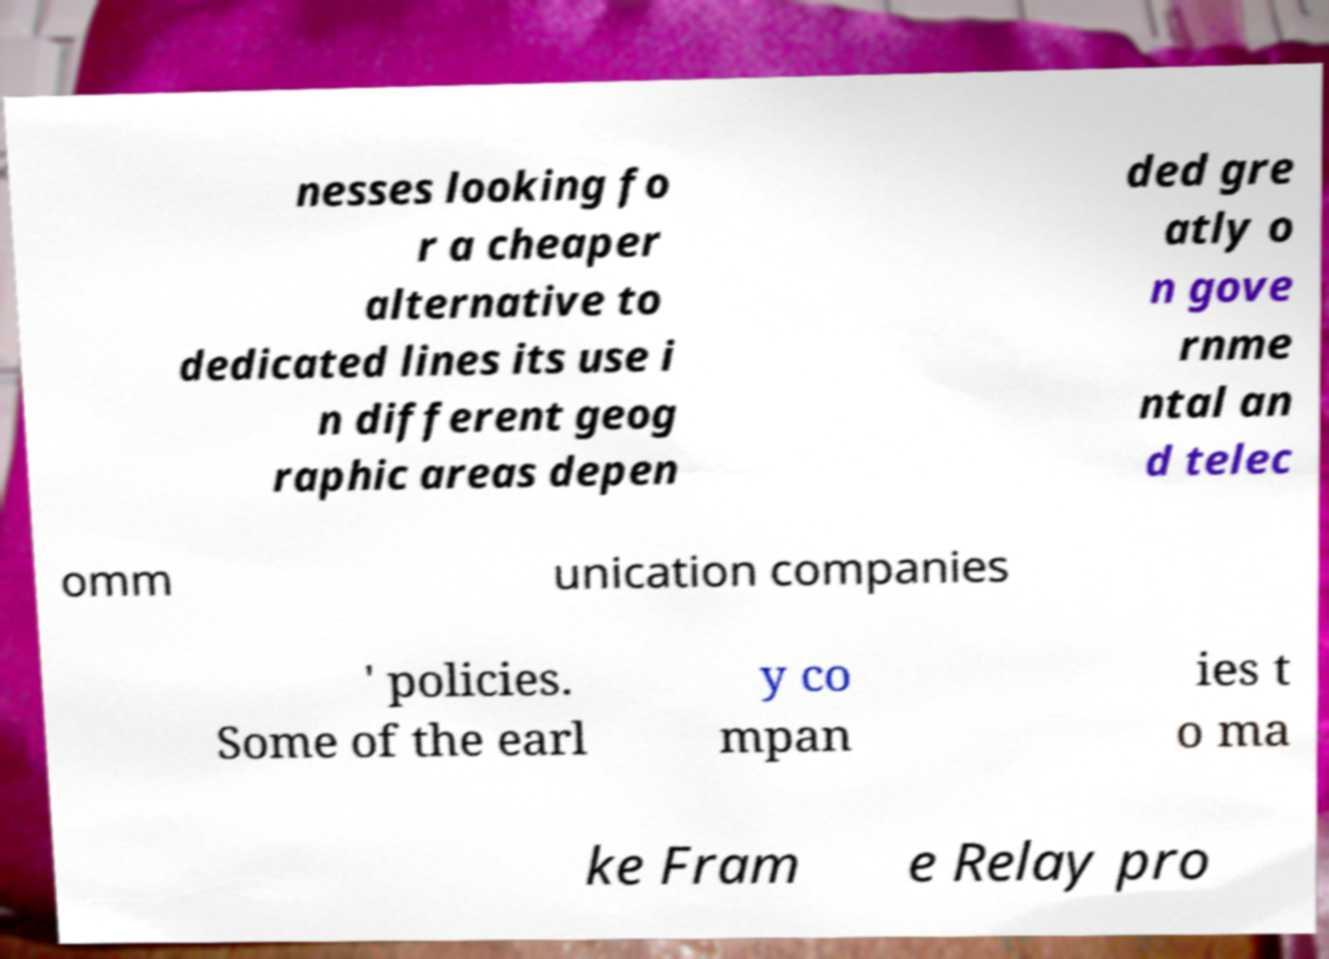Could you extract and type out the text from this image? nesses looking fo r a cheaper alternative to dedicated lines its use i n different geog raphic areas depen ded gre atly o n gove rnme ntal an d telec omm unication companies ' policies. Some of the earl y co mpan ies t o ma ke Fram e Relay pro 